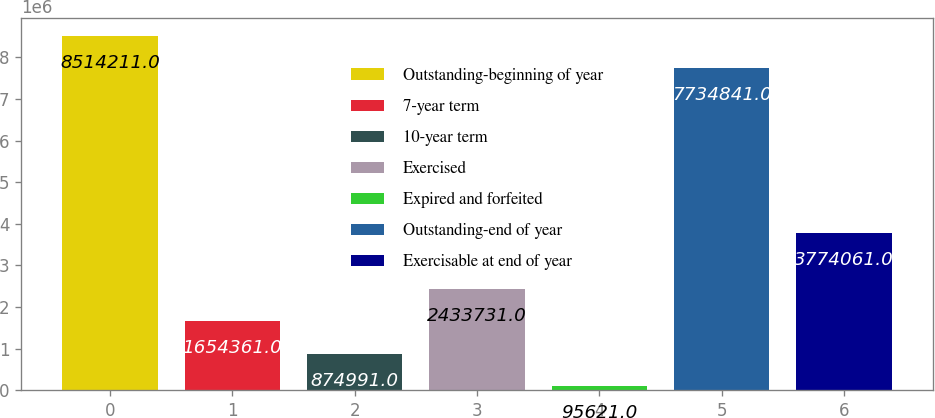Convert chart to OTSL. <chart><loc_0><loc_0><loc_500><loc_500><bar_chart><fcel>Outstanding-beginning of year<fcel>7-year term<fcel>10-year term<fcel>Exercised<fcel>Expired and forfeited<fcel>Outstanding-end of year<fcel>Exercisable at end of year<nl><fcel>8.51421e+06<fcel>1.65436e+06<fcel>874991<fcel>2.43373e+06<fcel>95621<fcel>7.73484e+06<fcel>3.77406e+06<nl></chart> 